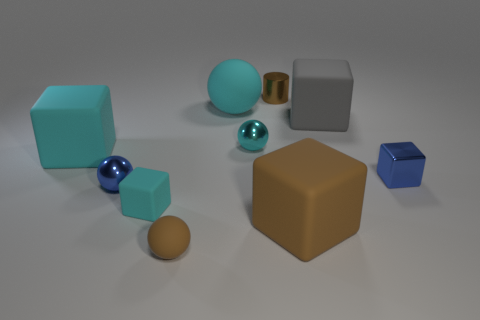Subtract all small brown spheres. How many spheres are left? 3 Subtract all cyan spheres. How many spheres are left? 2 Subtract all spheres. How many objects are left? 6 Subtract 2 spheres. How many spheres are left? 2 Subtract all brown blocks. Subtract all red cylinders. How many blocks are left? 4 Subtract all blue cubes. How many gray cylinders are left? 0 Subtract all large blue things. Subtract all gray matte objects. How many objects are left? 9 Add 4 tiny brown cylinders. How many tiny brown cylinders are left? 5 Add 3 big gray matte things. How many big gray matte things exist? 4 Subtract 1 brown cylinders. How many objects are left? 9 